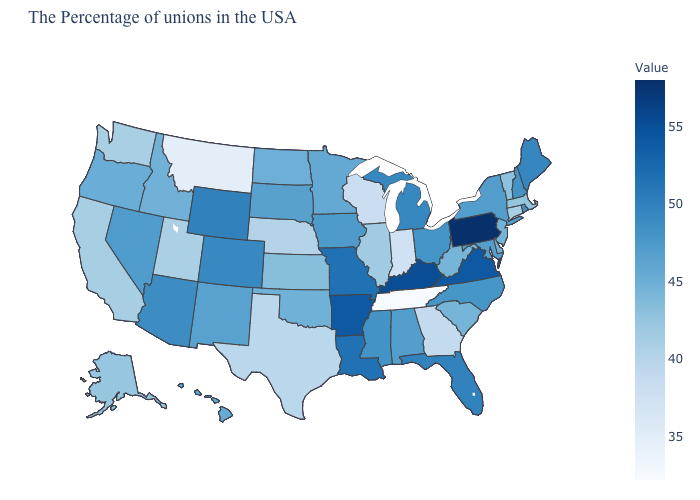Which states have the highest value in the USA?
Be succinct. Pennsylvania. Is the legend a continuous bar?
Give a very brief answer. Yes. Does the map have missing data?
Write a very short answer. No. Which states hav the highest value in the West?
Answer briefly. Wyoming. Does Minnesota have the lowest value in the USA?
Answer briefly. No. Is the legend a continuous bar?
Quick response, please. Yes. 